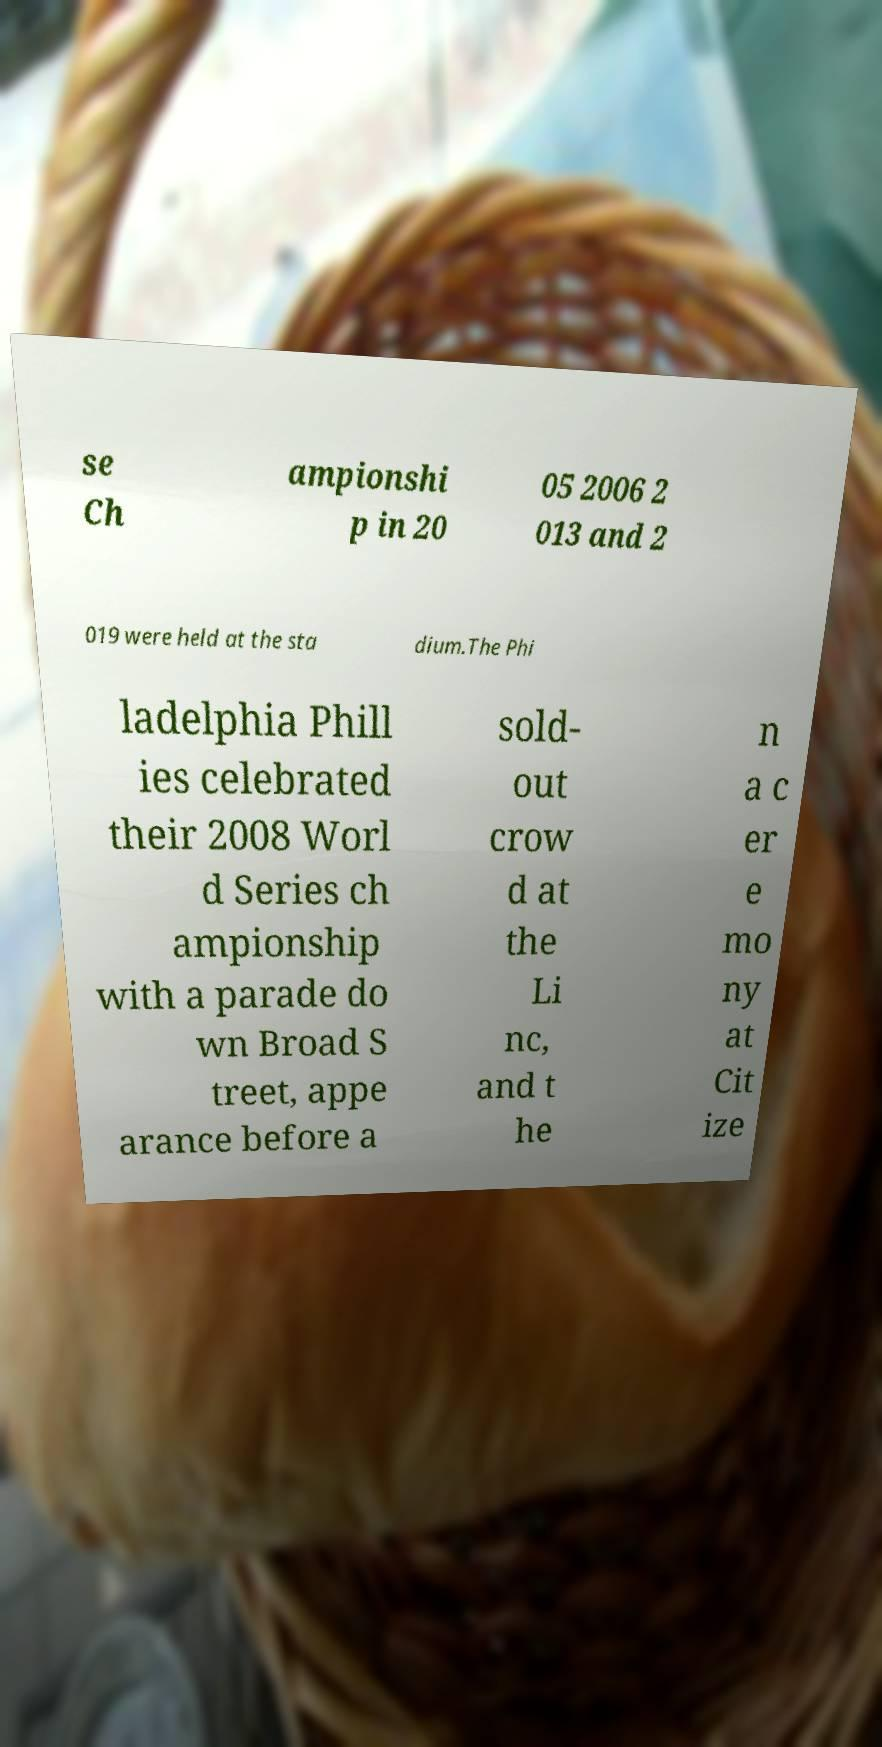Can you accurately transcribe the text from the provided image for me? se Ch ampionshi p in 20 05 2006 2 013 and 2 019 were held at the sta dium.The Phi ladelphia Phill ies celebrated their 2008 Worl d Series ch ampionship with a parade do wn Broad S treet, appe arance before a sold- out crow d at the Li nc, and t he n a c er e mo ny at Cit ize 